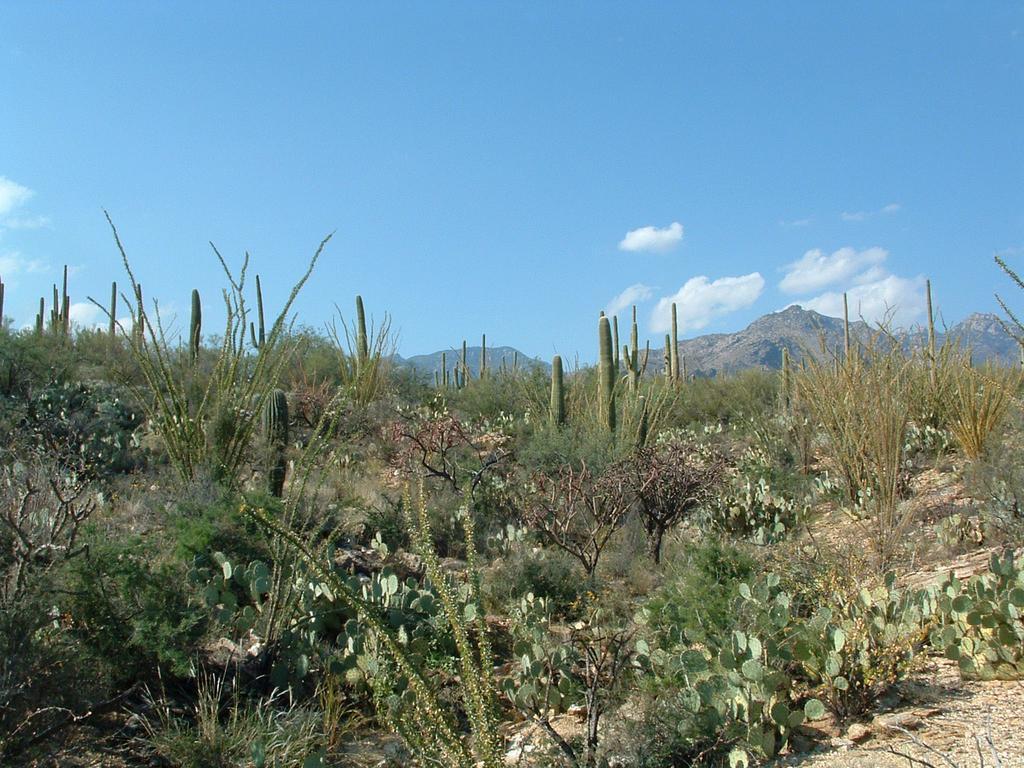How would you summarize this image in a sentence or two? In this picture we can see some plants, hills and grass. 